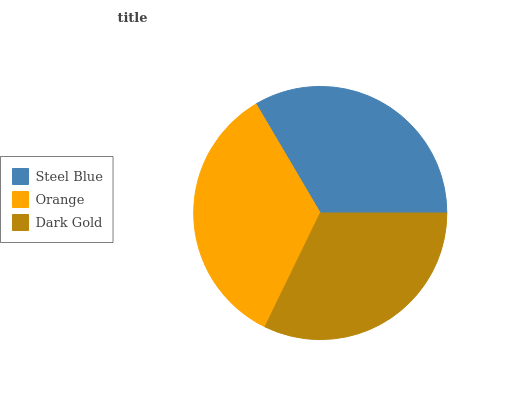Is Dark Gold the minimum?
Answer yes or no. Yes. Is Orange the maximum?
Answer yes or no. Yes. Is Orange the minimum?
Answer yes or no. No. Is Dark Gold the maximum?
Answer yes or no. No. Is Orange greater than Dark Gold?
Answer yes or no. Yes. Is Dark Gold less than Orange?
Answer yes or no. Yes. Is Dark Gold greater than Orange?
Answer yes or no. No. Is Orange less than Dark Gold?
Answer yes or no. No. Is Steel Blue the high median?
Answer yes or no. Yes. Is Steel Blue the low median?
Answer yes or no. Yes. Is Dark Gold the high median?
Answer yes or no. No. Is Orange the low median?
Answer yes or no. No. 